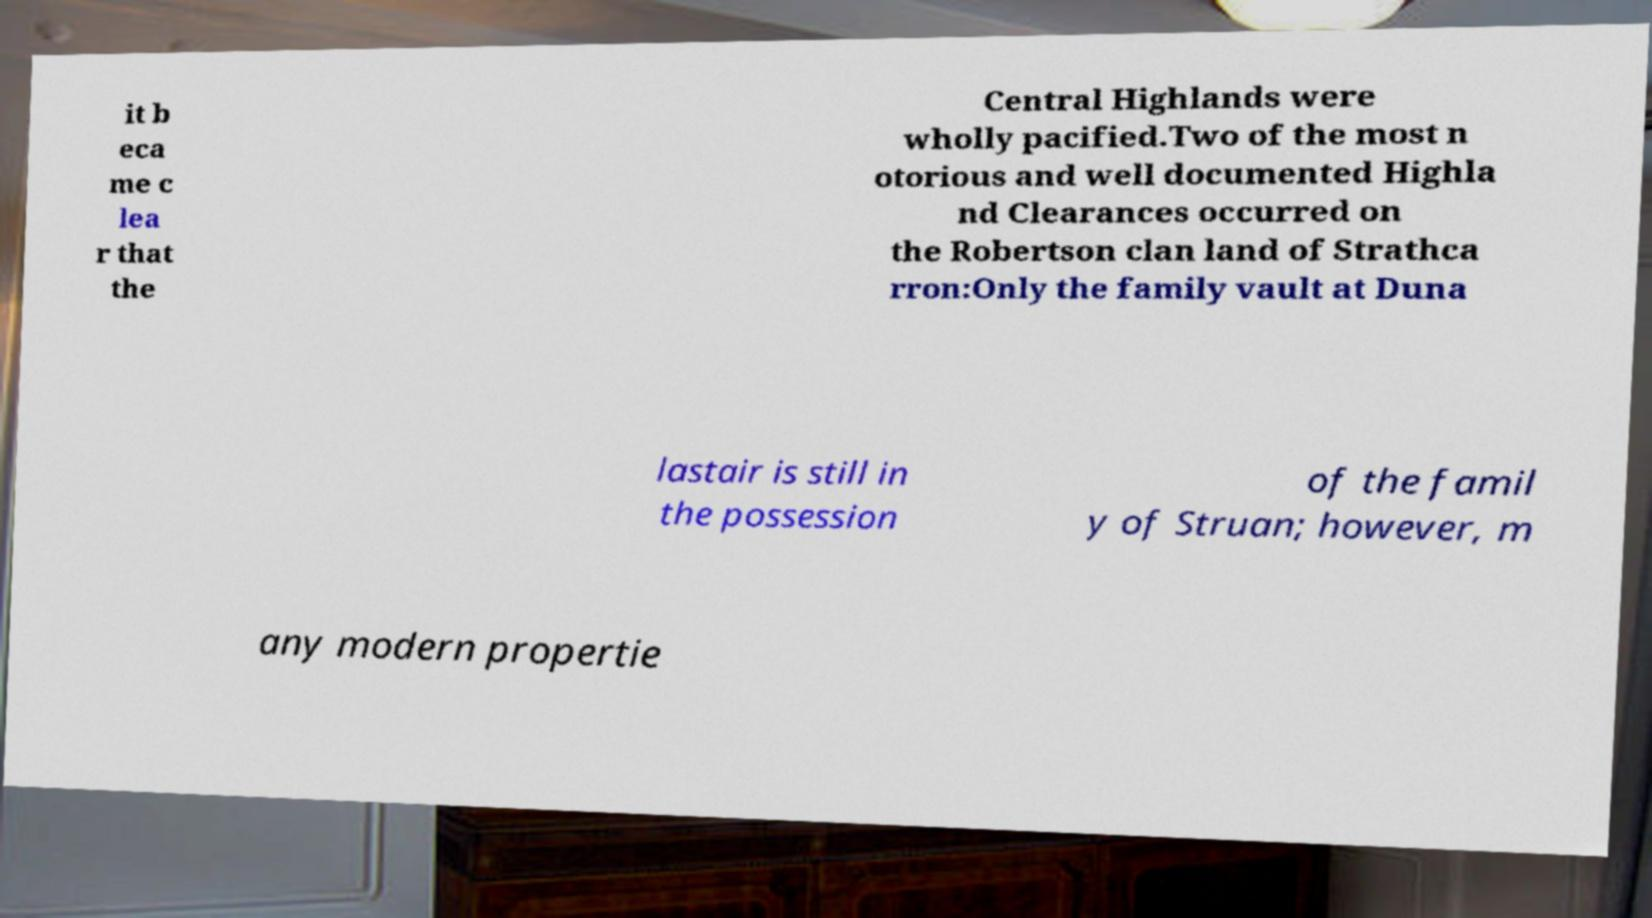Please identify and transcribe the text found in this image. it b eca me c lea r that the Central Highlands were wholly pacified.Two of the most n otorious and well documented Highla nd Clearances occurred on the Robertson clan land of Strathca rron:Only the family vault at Duna lastair is still in the possession of the famil y of Struan; however, m any modern propertie 